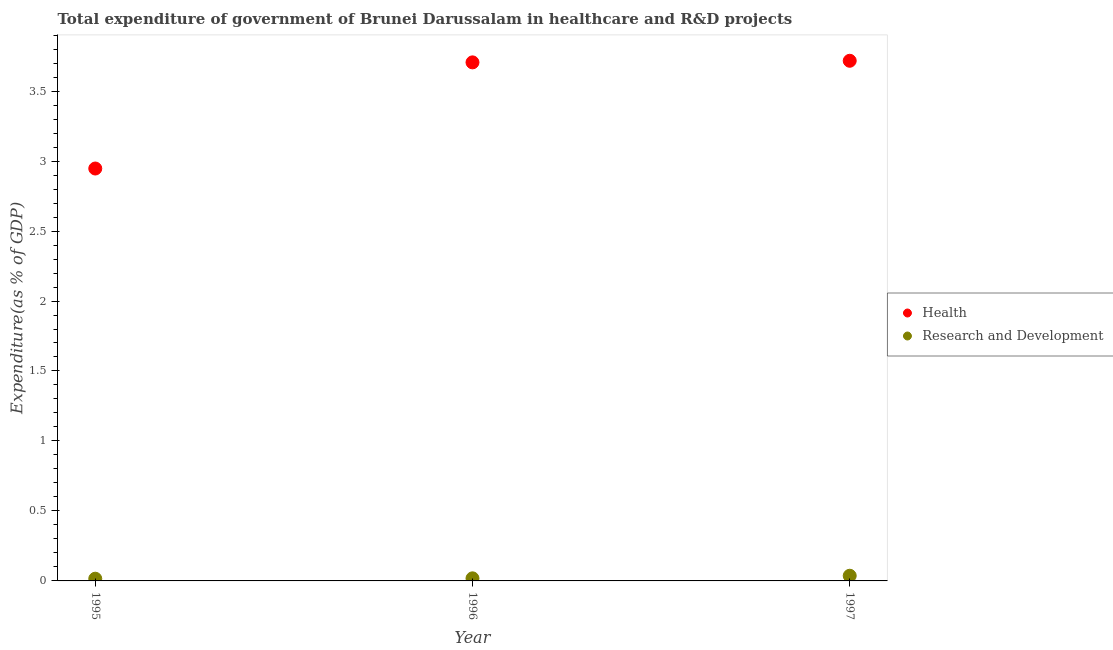How many different coloured dotlines are there?
Give a very brief answer. 2. Is the number of dotlines equal to the number of legend labels?
Your response must be concise. Yes. What is the expenditure in r&d in 1995?
Ensure brevity in your answer.  0.02. Across all years, what is the maximum expenditure in r&d?
Provide a succinct answer. 0.04. Across all years, what is the minimum expenditure in healthcare?
Provide a short and direct response. 2.95. In which year was the expenditure in healthcare minimum?
Offer a very short reply. 1995. What is the total expenditure in r&d in the graph?
Your answer should be compact. 0.07. What is the difference between the expenditure in r&d in 1996 and that in 1997?
Keep it short and to the point. -0.02. What is the difference between the expenditure in r&d in 1997 and the expenditure in healthcare in 1995?
Provide a short and direct response. -2.91. What is the average expenditure in healthcare per year?
Offer a terse response. 3.46. In the year 1997, what is the difference between the expenditure in healthcare and expenditure in r&d?
Ensure brevity in your answer.  3.68. In how many years, is the expenditure in healthcare greater than 2.8 %?
Provide a short and direct response. 3. What is the ratio of the expenditure in r&d in 1995 to that in 1996?
Offer a very short reply. 0.86. Is the expenditure in r&d in 1996 less than that in 1997?
Your answer should be compact. Yes. What is the difference between the highest and the second highest expenditure in r&d?
Keep it short and to the point. 0.02. What is the difference between the highest and the lowest expenditure in r&d?
Offer a very short reply. 0.02. In how many years, is the expenditure in r&d greater than the average expenditure in r&d taken over all years?
Your response must be concise. 1. Is the sum of the expenditure in healthcare in 1995 and 1997 greater than the maximum expenditure in r&d across all years?
Make the answer very short. Yes. Is the expenditure in healthcare strictly less than the expenditure in r&d over the years?
Make the answer very short. No. How many years are there in the graph?
Offer a terse response. 3. Does the graph contain any zero values?
Provide a succinct answer. No. Where does the legend appear in the graph?
Provide a short and direct response. Center right. How are the legend labels stacked?
Make the answer very short. Vertical. What is the title of the graph?
Provide a succinct answer. Total expenditure of government of Brunei Darussalam in healthcare and R&D projects. Does "Age 65(male)" appear as one of the legend labels in the graph?
Provide a short and direct response. No. What is the label or title of the Y-axis?
Provide a succinct answer. Expenditure(as % of GDP). What is the Expenditure(as % of GDP) in Health in 1995?
Offer a terse response. 2.95. What is the Expenditure(as % of GDP) of Research and Development in 1995?
Offer a very short reply. 0.02. What is the Expenditure(as % of GDP) of Health in 1996?
Make the answer very short. 3.71. What is the Expenditure(as % of GDP) of Research and Development in 1996?
Offer a very short reply. 0.02. What is the Expenditure(as % of GDP) of Health in 1997?
Ensure brevity in your answer.  3.72. What is the Expenditure(as % of GDP) of Research and Development in 1997?
Provide a succinct answer. 0.04. Across all years, what is the maximum Expenditure(as % of GDP) in Health?
Provide a succinct answer. 3.72. Across all years, what is the maximum Expenditure(as % of GDP) of Research and Development?
Offer a very short reply. 0.04. Across all years, what is the minimum Expenditure(as % of GDP) in Health?
Your answer should be very brief. 2.95. Across all years, what is the minimum Expenditure(as % of GDP) of Research and Development?
Keep it short and to the point. 0.02. What is the total Expenditure(as % of GDP) of Health in the graph?
Your response must be concise. 10.37. What is the total Expenditure(as % of GDP) of Research and Development in the graph?
Offer a terse response. 0.07. What is the difference between the Expenditure(as % of GDP) in Health in 1995 and that in 1996?
Keep it short and to the point. -0.76. What is the difference between the Expenditure(as % of GDP) of Research and Development in 1995 and that in 1996?
Offer a terse response. -0. What is the difference between the Expenditure(as % of GDP) in Health in 1995 and that in 1997?
Your answer should be very brief. -0.77. What is the difference between the Expenditure(as % of GDP) in Research and Development in 1995 and that in 1997?
Your answer should be very brief. -0.02. What is the difference between the Expenditure(as % of GDP) of Health in 1996 and that in 1997?
Your answer should be very brief. -0.01. What is the difference between the Expenditure(as % of GDP) in Research and Development in 1996 and that in 1997?
Offer a terse response. -0.02. What is the difference between the Expenditure(as % of GDP) of Health in 1995 and the Expenditure(as % of GDP) of Research and Development in 1996?
Your response must be concise. 2.93. What is the difference between the Expenditure(as % of GDP) of Health in 1995 and the Expenditure(as % of GDP) of Research and Development in 1997?
Your answer should be compact. 2.91. What is the difference between the Expenditure(as % of GDP) in Health in 1996 and the Expenditure(as % of GDP) in Research and Development in 1997?
Give a very brief answer. 3.67. What is the average Expenditure(as % of GDP) in Health per year?
Offer a terse response. 3.46. What is the average Expenditure(as % of GDP) of Research and Development per year?
Make the answer very short. 0.02. In the year 1995, what is the difference between the Expenditure(as % of GDP) in Health and Expenditure(as % of GDP) in Research and Development?
Ensure brevity in your answer.  2.93. In the year 1996, what is the difference between the Expenditure(as % of GDP) of Health and Expenditure(as % of GDP) of Research and Development?
Keep it short and to the point. 3.69. In the year 1997, what is the difference between the Expenditure(as % of GDP) in Health and Expenditure(as % of GDP) in Research and Development?
Make the answer very short. 3.68. What is the ratio of the Expenditure(as % of GDP) of Health in 1995 to that in 1996?
Your answer should be very brief. 0.8. What is the ratio of the Expenditure(as % of GDP) in Research and Development in 1995 to that in 1996?
Keep it short and to the point. 0.86. What is the ratio of the Expenditure(as % of GDP) in Health in 1995 to that in 1997?
Offer a very short reply. 0.79. What is the ratio of the Expenditure(as % of GDP) in Research and Development in 1995 to that in 1997?
Give a very brief answer. 0.43. What is the ratio of the Expenditure(as % of GDP) in Research and Development in 1996 to that in 1997?
Your answer should be compact. 0.5. What is the difference between the highest and the second highest Expenditure(as % of GDP) of Health?
Offer a terse response. 0.01. What is the difference between the highest and the second highest Expenditure(as % of GDP) in Research and Development?
Your answer should be compact. 0.02. What is the difference between the highest and the lowest Expenditure(as % of GDP) in Health?
Provide a succinct answer. 0.77. What is the difference between the highest and the lowest Expenditure(as % of GDP) in Research and Development?
Your response must be concise. 0.02. 